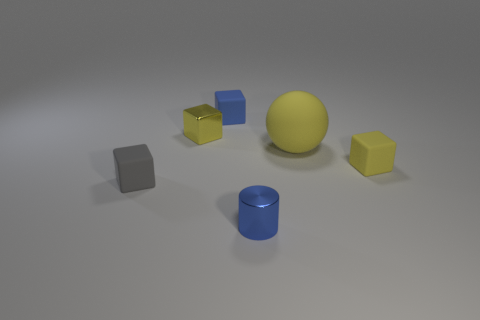There is a yellow thing that is made of the same material as the big yellow ball; what shape is it?
Ensure brevity in your answer.  Cube. How many small things are both behind the small gray rubber object and to the right of the small yellow shiny block?
Keep it short and to the point. 2. Are there any other things that have the same shape as the small gray matte object?
Your response must be concise. Yes. How big is the yellow block that is on the right side of the small cylinder?
Give a very brief answer. Small. How many other things are there of the same color as the small metallic cube?
Keep it short and to the point. 2. What is the yellow block on the right side of the blue object that is on the left side of the small metallic cylinder made of?
Your answer should be very brief. Rubber. There is a matte block behind the small yellow shiny object; does it have the same color as the cylinder?
Offer a very short reply. Yes. How many small yellow shiny things have the same shape as the gray rubber object?
Offer a very short reply. 1. There is a blue cube that is the same material as the sphere; what size is it?
Give a very brief answer. Small. Are there any small blue cylinders right of the small blue thing that is in front of the tiny blue thing that is on the left side of the small blue cylinder?
Give a very brief answer. No. 